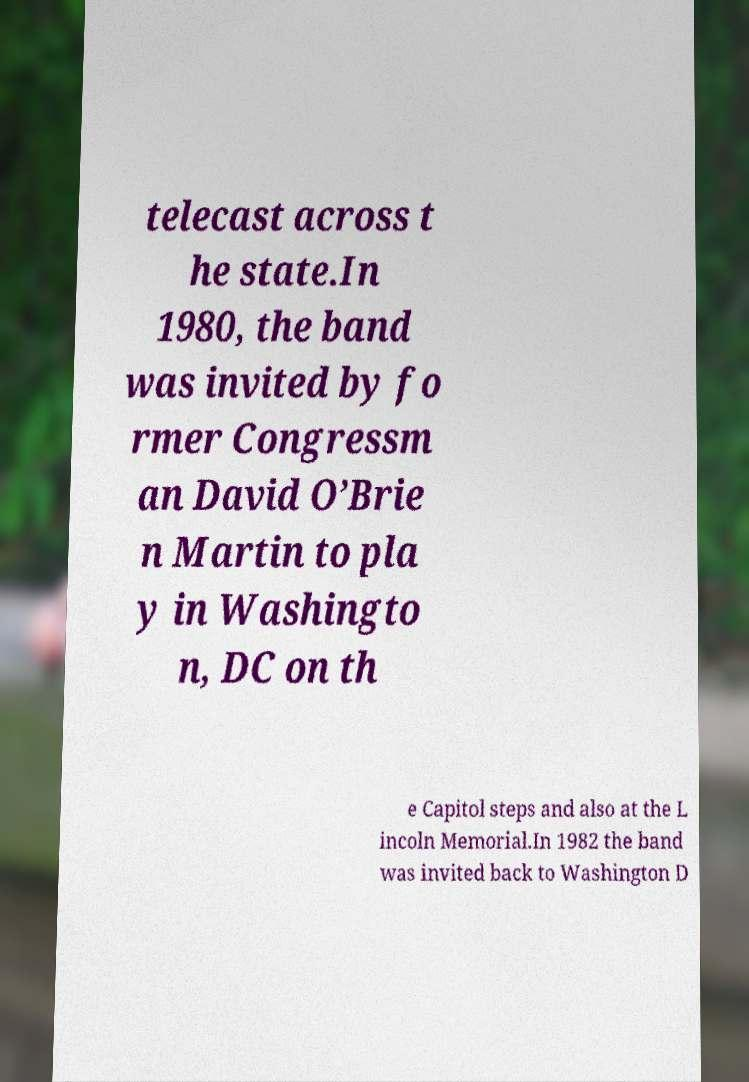Please read and relay the text visible in this image. What does it say? telecast across t he state.In 1980, the band was invited by fo rmer Congressm an David O’Brie n Martin to pla y in Washingto n, DC on th e Capitol steps and also at the L incoln Memorial.In 1982 the band was invited back to Washington D 